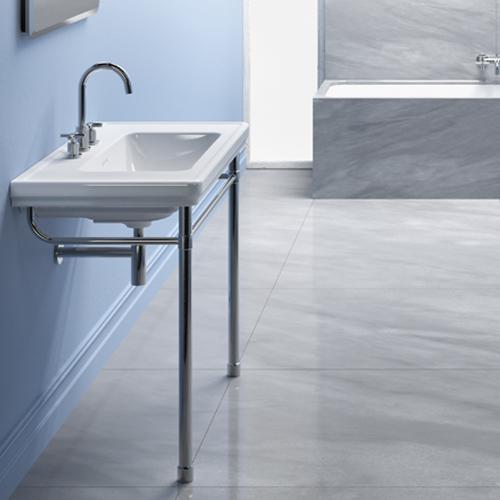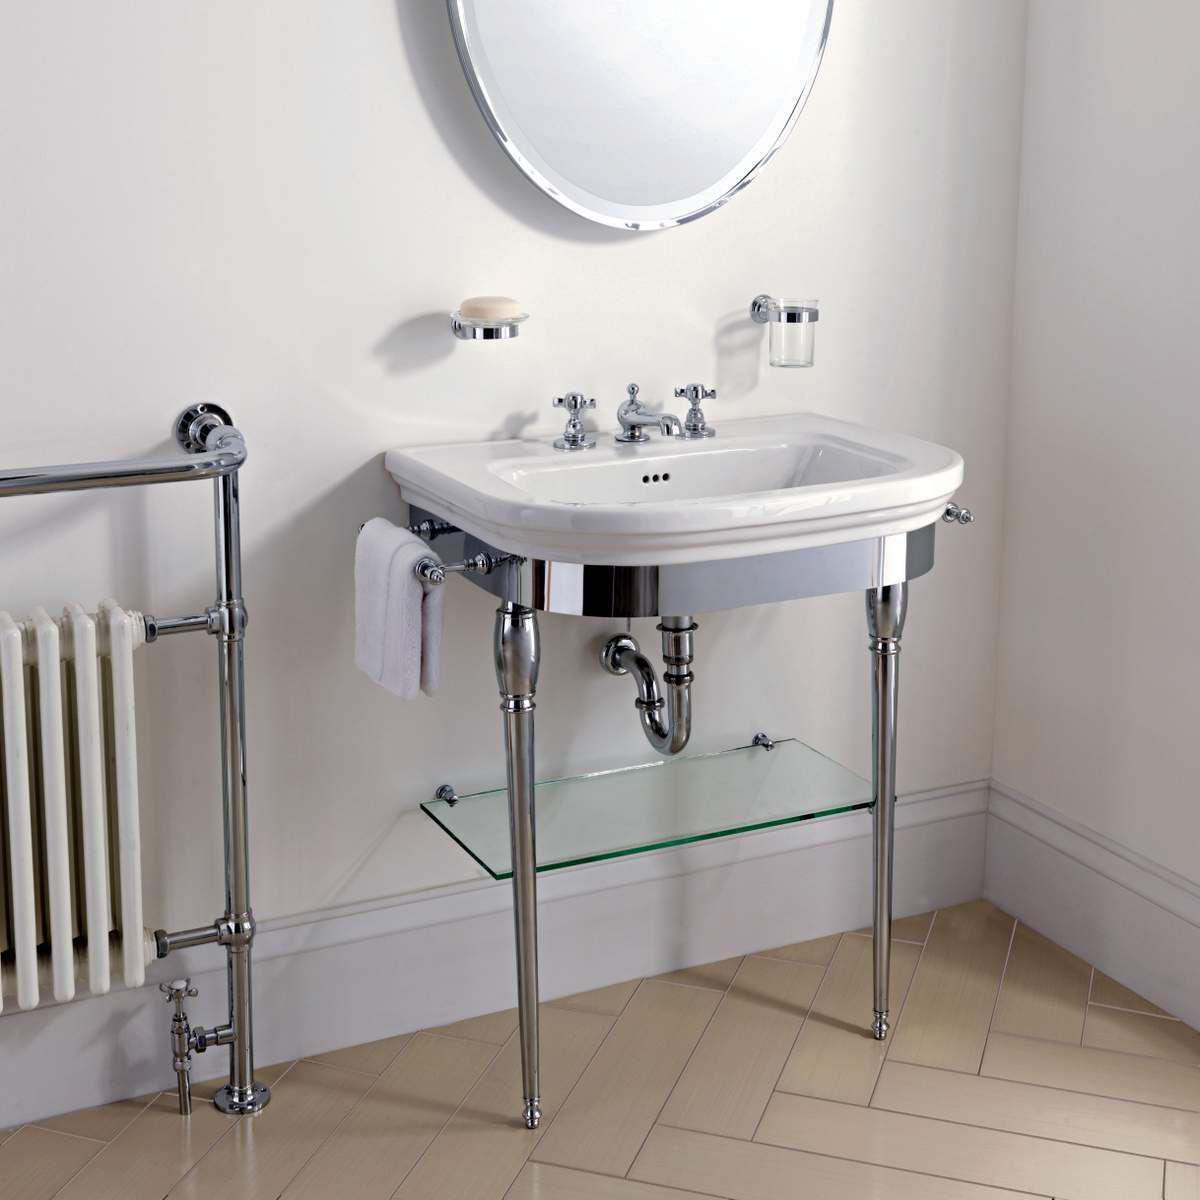The first image is the image on the left, the second image is the image on the right. Analyze the images presented: Is the assertion "A toilet is sitting in a room with a white baseboard in one of the images." valid? Answer yes or no. No. 